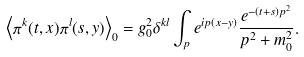Convert formula to latex. <formula><loc_0><loc_0><loc_500><loc_500>\left \langle \pi ^ { k } ( t , x ) \pi ^ { l } ( s , y ) \right \rangle _ { 0 } = g _ { 0 } ^ { 2 } \delta ^ { k l } \int _ { p } e ^ { i p ( x - y ) } \frac { e ^ { - ( t + s ) p ^ { 2 } } } { p ^ { 2 } + m _ { 0 } ^ { 2 } } .</formula> 